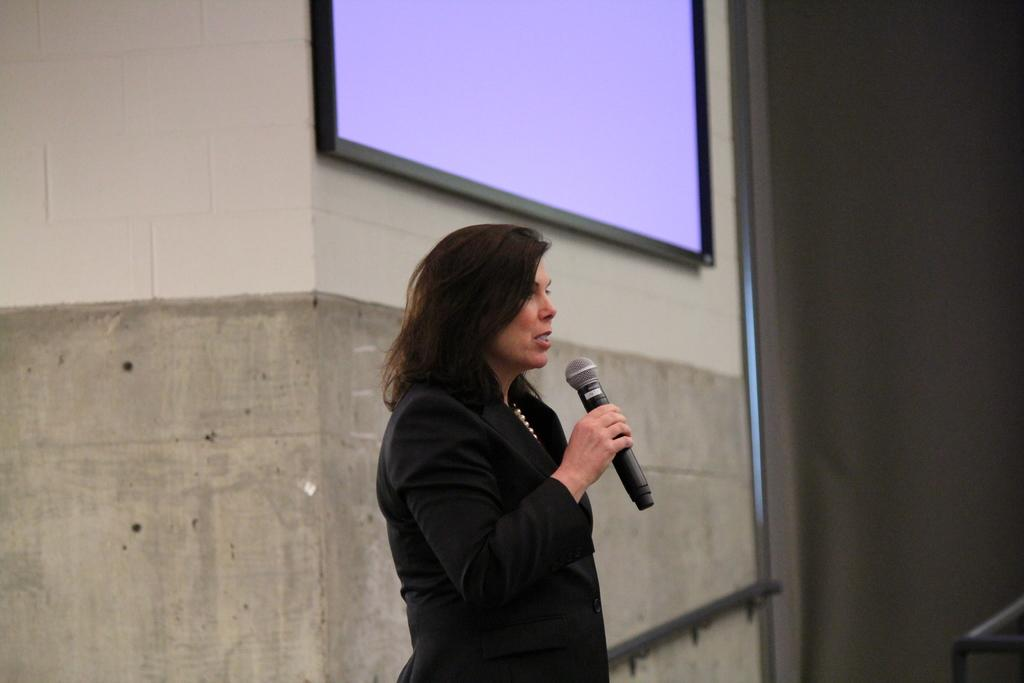What is the main subject of the image? There is a woman in the image. What is the woman doing in the image? The woman is standing and speaking into a microphone. How is the woman holding the microphone? The microphone is held in her right hand. What can be seen behind the woman in the image? There is a wall behind the woman, and a screen is on the wall. What type of snake is crawling on the screen in the image? There is no snake present in the image; it only features a woman standing and speaking into a microphone, with a screen on the wall. 